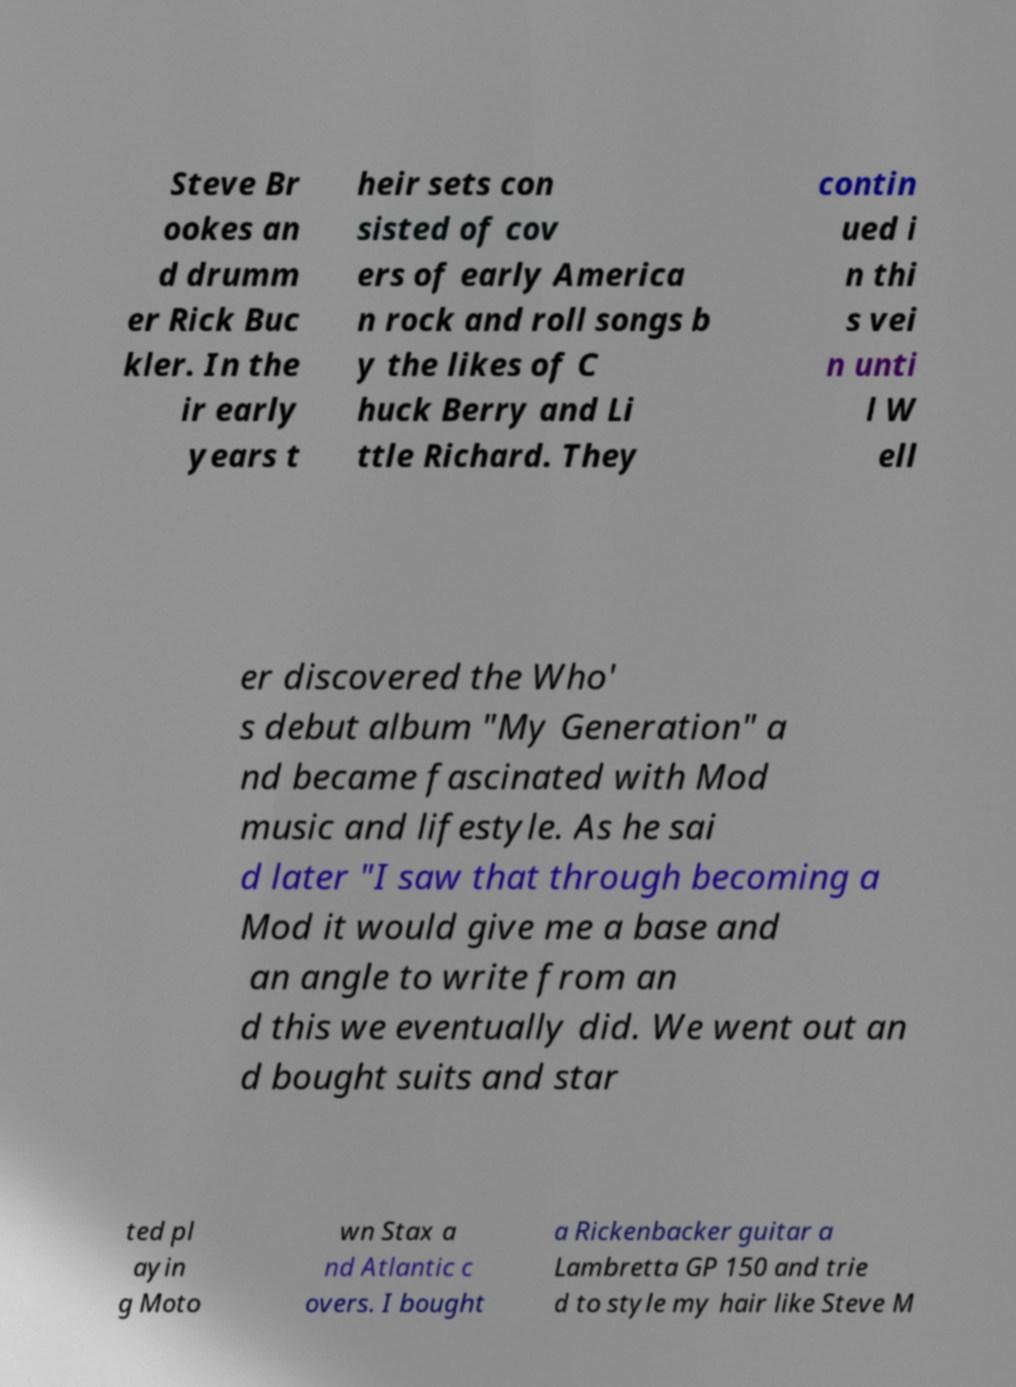There's text embedded in this image that I need extracted. Can you transcribe it verbatim? Steve Br ookes an d drumm er Rick Buc kler. In the ir early years t heir sets con sisted of cov ers of early America n rock and roll songs b y the likes of C huck Berry and Li ttle Richard. They contin ued i n thi s vei n unti l W ell er discovered the Who' s debut album "My Generation" a nd became fascinated with Mod music and lifestyle. As he sai d later "I saw that through becoming a Mod it would give me a base and an angle to write from an d this we eventually did. We went out an d bought suits and star ted pl ayin g Moto wn Stax a nd Atlantic c overs. I bought a Rickenbacker guitar a Lambretta GP 150 and trie d to style my hair like Steve M 